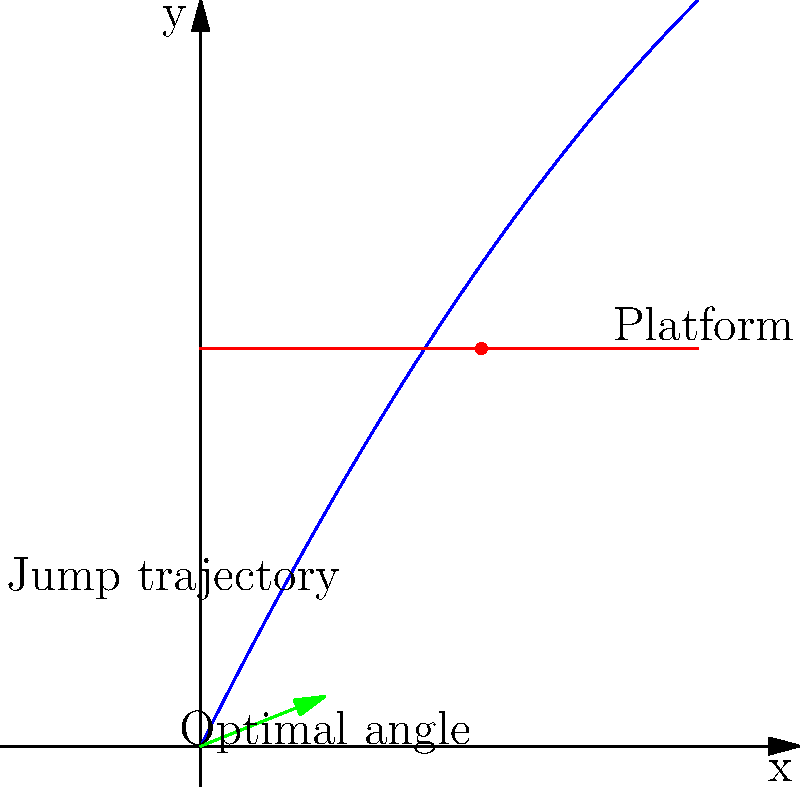In your latest platformer game, your character needs to jump onto a platform 8 units high. The jump trajectory follows the function $f(x) = -0.05x^2 + 2x$, where $x$ is the horizontal distance and $f(x)$ is the vertical distance. What is the optimal angle (in degrees) for the character to jump to reach the platform? Let's approach this step-by-step:

1) First, we need to find where the jump trajectory intersects with the platform. This occurs when $f(x) = 8$.

2) Solve the equation: $-0.05x^2 + 2x = 8$

3) Rearrange to standard form: $0.05x^2 - 2x + 8 = 0$

4) Use the quadratic formula: $x = \frac{-b \pm \sqrt{b^2 - 4ac}}{2a}$
   Where $a = 0.05$, $b = -2$, and $c = 8$

5) Solving this gives us $x \approx 5.65$ or $x \approx 34.35$. We'll use the smaller value as it's more realistic for the game.

6) At the start of the jump (x = 0), the trajectory's slope is equal to the tangent of the jump angle.

7) The derivative of $f(x)$ gives us this slope: $f'(x) = -0.1x + 2$

8) At $x = 0$, $f'(0) = 2$

9) The angle is therefore $\arctan(2)$

10) Convert to degrees: $\arctan(2) * (180/\pi) \approx 63.43°$
Answer: 63.43° 